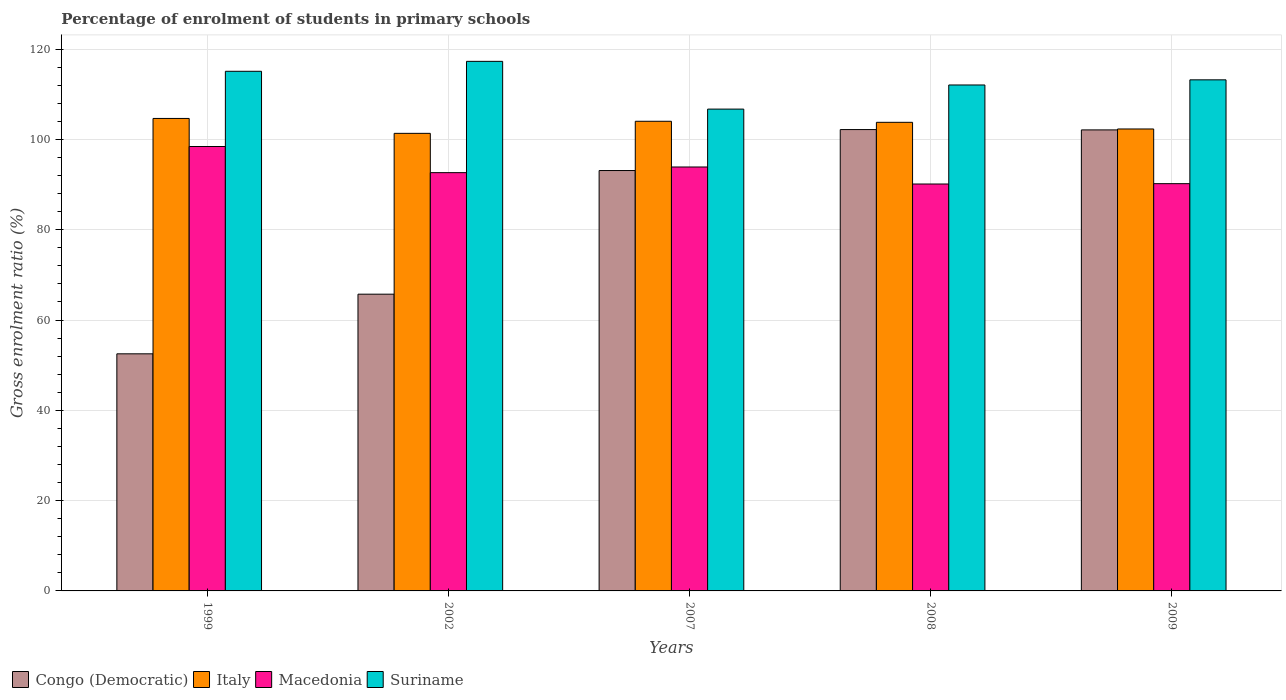What is the label of the 4th group of bars from the left?
Keep it short and to the point. 2008. In how many cases, is the number of bars for a given year not equal to the number of legend labels?
Keep it short and to the point. 0. What is the percentage of students enrolled in primary schools in Congo (Democratic) in 2002?
Your answer should be compact. 65.73. Across all years, what is the maximum percentage of students enrolled in primary schools in Macedonia?
Your answer should be very brief. 98.43. Across all years, what is the minimum percentage of students enrolled in primary schools in Macedonia?
Offer a terse response. 90.13. In which year was the percentage of students enrolled in primary schools in Congo (Democratic) maximum?
Provide a succinct answer. 2008. What is the total percentage of students enrolled in primary schools in Italy in the graph?
Ensure brevity in your answer.  516.12. What is the difference between the percentage of students enrolled in primary schools in Suriname in 2002 and that in 2009?
Keep it short and to the point. 4.09. What is the difference between the percentage of students enrolled in primary schools in Suriname in 2002 and the percentage of students enrolled in primary schools in Congo (Democratic) in 1999?
Offer a very short reply. 64.78. What is the average percentage of students enrolled in primary schools in Suriname per year?
Provide a short and direct response. 112.87. In the year 1999, what is the difference between the percentage of students enrolled in primary schools in Suriname and percentage of students enrolled in primary schools in Italy?
Provide a succinct answer. 10.45. In how many years, is the percentage of students enrolled in primary schools in Congo (Democratic) greater than 84 %?
Make the answer very short. 3. What is the ratio of the percentage of students enrolled in primary schools in Suriname in 1999 to that in 2008?
Your response must be concise. 1.03. Is the percentage of students enrolled in primary schools in Congo (Democratic) in 2007 less than that in 2008?
Give a very brief answer. Yes. Is the difference between the percentage of students enrolled in primary schools in Suriname in 1999 and 2009 greater than the difference between the percentage of students enrolled in primary schools in Italy in 1999 and 2009?
Your answer should be compact. No. What is the difference between the highest and the second highest percentage of students enrolled in primary schools in Italy?
Offer a terse response. 0.62. What is the difference between the highest and the lowest percentage of students enrolled in primary schools in Suriname?
Provide a short and direct response. 10.58. Is the sum of the percentage of students enrolled in primary schools in Congo (Democratic) in 1999 and 2008 greater than the maximum percentage of students enrolled in primary schools in Suriname across all years?
Ensure brevity in your answer.  Yes. What does the 3rd bar from the left in 1999 represents?
Make the answer very short. Macedonia. What does the 3rd bar from the right in 2009 represents?
Keep it short and to the point. Italy. How many bars are there?
Ensure brevity in your answer.  20. Are all the bars in the graph horizontal?
Provide a short and direct response. No. How many years are there in the graph?
Make the answer very short. 5. Does the graph contain any zero values?
Your answer should be very brief. No. How many legend labels are there?
Your answer should be very brief. 4. What is the title of the graph?
Provide a succinct answer. Percentage of enrolment of students in primary schools. What is the Gross enrolment ratio (%) in Congo (Democratic) in 1999?
Keep it short and to the point. 52.51. What is the Gross enrolment ratio (%) in Italy in 1999?
Give a very brief answer. 104.65. What is the Gross enrolment ratio (%) of Macedonia in 1999?
Ensure brevity in your answer.  98.43. What is the Gross enrolment ratio (%) of Suriname in 1999?
Your answer should be very brief. 115.09. What is the Gross enrolment ratio (%) of Congo (Democratic) in 2002?
Keep it short and to the point. 65.73. What is the Gross enrolment ratio (%) of Italy in 2002?
Keep it short and to the point. 101.35. What is the Gross enrolment ratio (%) of Macedonia in 2002?
Your response must be concise. 92.64. What is the Gross enrolment ratio (%) in Suriname in 2002?
Give a very brief answer. 117.29. What is the Gross enrolment ratio (%) in Congo (Democratic) in 2007?
Your response must be concise. 93.11. What is the Gross enrolment ratio (%) of Italy in 2007?
Keep it short and to the point. 104.02. What is the Gross enrolment ratio (%) in Macedonia in 2007?
Your response must be concise. 93.9. What is the Gross enrolment ratio (%) in Suriname in 2007?
Provide a short and direct response. 106.72. What is the Gross enrolment ratio (%) in Congo (Democratic) in 2008?
Make the answer very short. 102.18. What is the Gross enrolment ratio (%) of Italy in 2008?
Offer a very short reply. 103.79. What is the Gross enrolment ratio (%) in Macedonia in 2008?
Your answer should be very brief. 90.13. What is the Gross enrolment ratio (%) of Suriname in 2008?
Provide a succinct answer. 112.06. What is the Gross enrolment ratio (%) in Congo (Democratic) in 2009?
Make the answer very short. 102.11. What is the Gross enrolment ratio (%) of Italy in 2009?
Your answer should be compact. 102.32. What is the Gross enrolment ratio (%) in Macedonia in 2009?
Your answer should be compact. 90.2. What is the Gross enrolment ratio (%) of Suriname in 2009?
Give a very brief answer. 113.2. Across all years, what is the maximum Gross enrolment ratio (%) of Congo (Democratic)?
Offer a very short reply. 102.18. Across all years, what is the maximum Gross enrolment ratio (%) of Italy?
Make the answer very short. 104.65. Across all years, what is the maximum Gross enrolment ratio (%) of Macedonia?
Make the answer very short. 98.43. Across all years, what is the maximum Gross enrolment ratio (%) in Suriname?
Your response must be concise. 117.29. Across all years, what is the minimum Gross enrolment ratio (%) of Congo (Democratic)?
Your answer should be very brief. 52.51. Across all years, what is the minimum Gross enrolment ratio (%) in Italy?
Your response must be concise. 101.35. Across all years, what is the minimum Gross enrolment ratio (%) in Macedonia?
Give a very brief answer. 90.13. Across all years, what is the minimum Gross enrolment ratio (%) in Suriname?
Provide a succinct answer. 106.72. What is the total Gross enrolment ratio (%) of Congo (Democratic) in the graph?
Your response must be concise. 415.64. What is the total Gross enrolment ratio (%) of Italy in the graph?
Give a very brief answer. 516.12. What is the total Gross enrolment ratio (%) in Macedonia in the graph?
Your response must be concise. 465.3. What is the total Gross enrolment ratio (%) of Suriname in the graph?
Your response must be concise. 564.36. What is the difference between the Gross enrolment ratio (%) in Congo (Democratic) in 1999 and that in 2002?
Offer a terse response. -13.21. What is the difference between the Gross enrolment ratio (%) of Italy in 1999 and that in 2002?
Your response must be concise. 3.3. What is the difference between the Gross enrolment ratio (%) of Macedonia in 1999 and that in 2002?
Make the answer very short. 5.79. What is the difference between the Gross enrolment ratio (%) of Suriname in 1999 and that in 2002?
Offer a terse response. -2.2. What is the difference between the Gross enrolment ratio (%) of Congo (Democratic) in 1999 and that in 2007?
Your response must be concise. -40.59. What is the difference between the Gross enrolment ratio (%) of Italy in 1999 and that in 2007?
Provide a succinct answer. 0.62. What is the difference between the Gross enrolment ratio (%) of Macedonia in 1999 and that in 2007?
Make the answer very short. 4.54. What is the difference between the Gross enrolment ratio (%) in Suriname in 1999 and that in 2007?
Your answer should be very brief. 8.38. What is the difference between the Gross enrolment ratio (%) of Congo (Democratic) in 1999 and that in 2008?
Provide a short and direct response. -49.67. What is the difference between the Gross enrolment ratio (%) of Italy in 1999 and that in 2008?
Make the answer very short. 0.86. What is the difference between the Gross enrolment ratio (%) of Macedonia in 1999 and that in 2008?
Keep it short and to the point. 8.31. What is the difference between the Gross enrolment ratio (%) of Suriname in 1999 and that in 2008?
Offer a very short reply. 3.03. What is the difference between the Gross enrolment ratio (%) in Congo (Democratic) in 1999 and that in 2009?
Provide a succinct answer. -49.6. What is the difference between the Gross enrolment ratio (%) of Italy in 1999 and that in 2009?
Your answer should be compact. 2.33. What is the difference between the Gross enrolment ratio (%) in Macedonia in 1999 and that in 2009?
Offer a terse response. 8.23. What is the difference between the Gross enrolment ratio (%) in Suriname in 1999 and that in 2009?
Offer a very short reply. 1.89. What is the difference between the Gross enrolment ratio (%) in Congo (Democratic) in 2002 and that in 2007?
Make the answer very short. -27.38. What is the difference between the Gross enrolment ratio (%) in Italy in 2002 and that in 2007?
Offer a very short reply. -2.68. What is the difference between the Gross enrolment ratio (%) in Macedonia in 2002 and that in 2007?
Offer a very short reply. -1.25. What is the difference between the Gross enrolment ratio (%) in Suriname in 2002 and that in 2007?
Provide a succinct answer. 10.58. What is the difference between the Gross enrolment ratio (%) in Congo (Democratic) in 2002 and that in 2008?
Offer a terse response. -36.46. What is the difference between the Gross enrolment ratio (%) in Italy in 2002 and that in 2008?
Offer a terse response. -2.44. What is the difference between the Gross enrolment ratio (%) of Macedonia in 2002 and that in 2008?
Your answer should be compact. 2.52. What is the difference between the Gross enrolment ratio (%) in Suriname in 2002 and that in 2008?
Give a very brief answer. 5.23. What is the difference between the Gross enrolment ratio (%) of Congo (Democratic) in 2002 and that in 2009?
Offer a very short reply. -36.38. What is the difference between the Gross enrolment ratio (%) in Italy in 2002 and that in 2009?
Your response must be concise. -0.97. What is the difference between the Gross enrolment ratio (%) of Macedonia in 2002 and that in 2009?
Provide a short and direct response. 2.44. What is the difference between the Gross enrolment ratio (%) in Suriname in 2002 and that in 2009?
Keep it short and to the point. 4.09. What is the difference between the Gross enrolment ratio (%) in Congo (Democratic) in 2007 and that in 2008?
Your response must be concise. -9.08. What is the difference between the Gross enrolment ratio (%) in Italy in 2007 and that in 2008?
Your answer should be compact. 0.23. What is the difference between the Gross enrolment ratio (%) in Macedonia in 2007 and that in 2008?
Ensure brevity in your answer.  3.77. What is the difference between the Gross enrolment ratio (%) of Suriname in 2007 and that in 2008?
Ensure brevity in your answer.  -5.34. What is the difference between the Gross enrolment ratio (%) in Congo (Democratic) in 2007 and that in 2009?
Provide a succinct answer. -9. What is the difference between the Gross enrolment ratio (%) in Italy in 2007 and that in 2009?
Offer a terse response. 1.71. What is the difference between the Gross enrolment ratio (%) of Macedonia in 2007 and that in 2009?
Provide a short and direct response. 3.69. What is the difference between the Gross enrolment ratio (%) of Suriname in 2007 and that in 2009?
Your answer should be very brief. -6.48. What is the difference between the Gross enrolment ratio (%) of Congo (Democratic) in 2008 and that in 2009?
Provide a succinct answer. 0.07. What is the difference between the Gross enrolment ratio (%) in Italy in 2008 and that in 2009?
Your answer should be compact. 1.47. What is the difference between the Gross enrolment ratio (%) in Macedonia in 2008 and that in 2009?
Your response must be concise. -0.08. What is the difference between the Gross enrolment ratio (%) of Suriname in 2008 and that in 2009?
Provide a succinct answer. -1.14. What is the difference between the Gross enrolment ratio (%) in Congo (Democratic) in 1999 and the Gross enrolment ratio (%) in Italy in 2002?
Keep it short and to the point. -48.83. What is the difference between the Gross enrolment ratio (%) of Congo (Democratic) in 1999 and the Gross enrolment ratio (%) of Macedonia in 2002?
Give a very brief answer. -40.13. What is the difference between the Gross enrolment ratio (%) of Congo (Democratic) in 1999 and the Gross enrolment ratio (%) of Suriname in 2002?
Your answer should be compact. -64.78. What is the difference between the Gross enrolment ratio (%) in Italy in 1999 and the Gross enrolment ratio (%) in Macedonia in 2002?
Your answer should be compact. 12. What is the difference between the Gross enrolment ratio (%) of Italy in 1999 and the Gross enrolment ratio (%) of Suriname in 2002?
Give a very brief answer. -12.65. What is the difference between the Gross enrolment ratio (%) in Macedonia in 1999 and the Gross enrolment ratio (%) in Suriname in 2002?
Provide a short and direct response. -18.86. What is the difference between the Gross enrolment ratio (%) of Congo (Democratic) in 1999 and the Gross enrolment ratio (%) of Italy in 2007?
Keep it short and to the point. -51.51. What is the difference between the Gross enrolment ratio (%) in Congo (Democratic) in 1999 and the Gross enrolment ratio (%) in Macedonia in 2007?
Ensure brevity in your answer.  -41.38. What is the difference between the Gross enrolment ratio (%) of Congo (Democratic) in 1999 and the Gross enrolment ratio (%) of Suriname in 2007?
Ensure brevity in your answer.  -54.2. What is the difference between the Gross enrolment ratio (%) of Italy in 1999 and the Gross enrolment ratio (%) of Macedonia in 2007?
Provide a succinct answer. 10.75. What is the difference between the Gross enrolment ratio (%) in Italy in 1999 and the Gross enrolment ratio (%) in Suriname in 2007?
Make the answer very short. -2.07. What is the difference between the Gross enrolment ratio (%) of Macedonia in 1999 and the Gross enrolment ratio (%) of Suriname in 2007?
Provide a short and direct response. -8.28. What is the difference between the Gross enrolment ratio (%) of Congo (Democratic) in 1999 and the Gross enrolment ratio (%) of Italy in 2008?
Offer a very short reply. -51.28. What is the difference between the Gross enrolment ratio (%) in Congo (Democratic) in 1999 and the Gross enrolment ratio (%) in Macedonia in 2008?
Ensure brevity in your answer.  -37.61. What is the difference between the Gross enrolment ratio (%) of Congo (Democratic) in 1999 and the Gross enrolment ratio (%) of Suriname in 2008?
Ensure brevity in your answer.  -59.55. What is the difference between the Gross enrolment ratio (%) of Italy in 1999 and the Gross enrolment ratio (%) of Macedonia in 2008?
Offer a terse response. 14.52. What is the difference between the Gross enrolment ratio (%) of Italy in 1999 and the Gross enrolment ratio (%) of Suriname in 2008?
Offer a terse response. -7.41. What is the difference between the Gross enrolment ratio (%) of Macedonia in 1999 and the Gross enrolment ratio (%) of Suriname in 2008?
Ensure brevity in your answer.  -13.63. What is the difference between the Gross enrolment ratio (%) of Congo (Democratic) in 1999 and the Gross enrolment ratio (%) of Italy in 2009?
Offer a terse response. -49.8. What is the difference between the Gross enrolment ratio (%) in Congo (Democratic) in 1999 and the Gross enrolment ratio (%) in Macedonia in 2009?
Ensure brevity in your answer.  -37.69. What is the difference between the Gross enrolment ratio (%) of Congo (Democratic) in 1999 and the Gross enrolment ratio (%) of Suriname in 2009?
Provide a succinct answer. -60.69. What is the difference between the Gross enrolment ratio (%) in Italy in 1999 and the Gross enrolment ratio (%) in Macedonia in 2009?
Provide a short and direct response. 14.44. What is the difference between the Gross enrolment ratio (%) of Italy in 1999 and the Gross enrolment ratio (%) of Suriname in 2009?
Your answer should be very brief. -8.55. What is the difference between the Gross enrolment ratio (%) in Macedonia in 1999 and the Gross enrolment ratio (%) in Suriname in 2009?
Give a very brief answer. -14.77. What is the difference between the Gross enrolment ratio (%) in Congo (Democratic) in 2002 and the Gross enrolment ratio (%) in Italy in 2007?
Give a very brief answer. -38.3. What is the difference between the Gross enrolment ratio (%) in Congo (Democratic) in 2002 and the Gross enrolment ratio (%) in Macedonia in 2007?
Ensure brevity in your answer.  -28.17. What is the difference between the Gross enrolment ratio (%) of Congo (Democratic) in 2002 and the Gross enrolment ratio (%) of Suriname in 2007?
Make the answer very short. -40.99. What is the difference between the Gross enrolment ratio (%) in Italy in 2002 and the Gross enrolment ratio (%) in Macedonia in 2007?
Provide a short and direct response. 7.45. What is the difference between the Gross enrolment ratio (%) in Italy in 2002 and the Gross enrolment ratio (%) in Suriname in 2007?
Offer a very short reply. -5.37. What is the difference between the Gross enrolment ratio (%) in Macedonia in 2002 and the Gross enrolment ratio (%) in Suriname in 2007?
Offer a terse response. -14.07. What is the difference between the Gross enrolment ratio (%) in Congo (Democratic) in 2002 and the Gross enrolment ratio (%) in Italy in 2008?
Offer a terse response. -38.06. What is the difference between the Gross enrolment ratio (%) of Congo (Democratic) in 2002 and the Gross enrolment ratio (%) of Macedonia in 2008?
Provide a short and direct response. -24.4. What is the difference between the Gross enrolment ratio (%) in Congo (Democratic) in 2002 and the Gross enrolment ratio (%) in Suriname in 2008?
Provide a succinct answer. -46.33. What is the difference between the Gross enrolment ratio (%) in Italy in 2002 and the Gross enrolment ratio (%) in Macedonia in 2008?
Make the answer very short. 11.22. What is the difference between the Gross enrolment ratio (%) of Italy in 2002 and the Gross enrolment ratio (%) of Suriname in 2008?
Your answer should be very brief. -10.71. What is the difference between the Gross enrolment ratio (%) of Macedonia in 2002 and the Gross enrolment ratio (%) of Suriname in 2008?
Your response must be concise. -19.42. What is the difference between the Gross enrolment ratio (%) in Congo (Democratic) in 2002 and the Gross enrolment ratio (%) in Italy in 2009?
Your response must be concise. -36.59. What is the difference between the Gross enrolment ratio (%) of Congo (Democratic) in 2002 and the Gross enrolment ratio (%) of Macedonia in 2009?
Offer a terse response. -24.48. What is the difference between the Gross enrolment ratio (%) in Congo (Democratic) in 2002 and the Gross enrolment ratio (%) in Suriname in 2009?
Your answer should be very brief. -47.47. What is the difference between the Gross enrolment ratio (%) of Italy in 2002 and the Gross enrolment ratio (%) of Macedonia in 2009?
Ensure brevity in your answer.  11.14. What is the difference between the Gross enrolment ratio (%) in Italy in 2002 and the Gross enrolment ratio (%) in Suriname in 2009?
Keep it short and to the point. -11.85. What is the difference between the Gross enrolment ratio (%) in Macedonia in 2002 and the Gross enrolment ratio (%) in Suriname in 2009?
Provide a short and direct response. -20.56. What is the difference between the Gross enrolment ratio (%) of Congo (Democratic) in 2007 and the Gross enrolment ratio (%) of Italy in 2008?
Give a very brief answer. -10.68. What is the difference between the Gross enrolment ratio (%) in Congo (Democratic) in 2007 and the Gross enrolment ratio (%) in Macedonia in 2008?
Keep it short and to the point. 2.98. What is the difference between the Gross enrolment ratio (%) in Congo (Democratic) in 2007 and the Gross enrolment ratio (%) in Suriname in 2008?
Offer a very short reply. -18.95. What is the difference between the Gross enrolment ratio (%) of Italy in 2007 and the Gross enrolment ratio (%) of Macedonia in 2008?
Your answer should be compact. 13.9. What is the difference between the Gross enrolment ratio (%) in Italy in 2007 and the Gross enrolment ratio (%) in Suriname in 2008?
Provide a short and direct response. -8.04. What is the difference between the Gross enrolment ratio (%) of Macedonia in 2007 and the Gross enrolment ratio (%) of Suriname in 2008?
Provide a succinct answer. -18.16. What is the difference between the Gross enrolment ratio (%) in Congo (Democratic) in 2007 and the Gross enrolment ratio (%) in Italy in 2009?
Provide a succinct answer. -9.21. What is the difference between the Gross enrolment ratio (%) in Congo (Democratic) in 2007 and the Gross enrolment ratio (%) in Macedonia in 2009?
Offer a terse response. 2.91. What is the difference between the Gross enrolment ratio (%) of Congo (Democratic) in 2007 and the Gross enrolment ratio (%) of Suriname in 2009?
Keep it short and to the point. -20.09. What is the difference between the Gross enrolment ratio (%) in Italy in 2007 and the Gross enrolment ratio (%) in Macedonia in 2009?
Give a very brief answer. 13.82. What is the difference between the Gross enrolment ratio (%) in Italy in 2007 and the Gross enrolment ratio (%) in Suriname in 2009?
Offer a terse response. -9.18. What is the difference between the Gross enrolment ratio (%) in Macedonia in 2007 and the Gross enrolment ratio (%) in Suriname in 2009?
Your answer should be compact. -19.3. What is the difference between the Gross enrolment ratio (%) of Congo (Democratic) in 2008 and the Gross enrolment ratio (%) of Italy in 2009?
Offer a terse response. -0.13. What is the difference between the Gross enrolment ratio (%) in Congo (Democratic) in 2008 and the Gross enrolment ratio (%) in Macedonia in 2009?
Ensure brevity in your answer.  11.98. What is the difference between the Gross enrolment ratio (%) in Congo (Democratic) in 2008 and the Gross enrolment ratio (%) in Suriname in 2009?
Your response must be concise. -11.02. What is the difference between the Gross enrolment ratio (%) of Italy in 2008 and the Gross enrolment ratio (%) of Macedonia in 2009?
Make the answer very short. 13.59. What is the difference between the Gross enrolment ratio (%) of Italy in 2008 and the Gross enrolment ratio (%) of Suriname in 2009?
Offer a terse response. -9.41. What is the difference between the Gross enrolment ratio (%) in Macedonia in 2008 and the Gross enrolment ratio (%) in Suriname in 2009?
Offer a terse response. -23.07. What is the average Gross enrolment ratio (%) of Congo (Democratic) per year?
Keep it short and to the point. 83.13. What is the average Gross enrolment ratio (%) in Italy per year?
Offer a very short reply. 103.22. What is the average Gross enrolment ratio (%) in Macedonia per year?
Give a very brief answer. 93.06. What is the average Gross enrolment ratio (%) in Suriname per year?
Provide a short and direct response. 112.87. In the year 1999, what is the difference between the Gross enrolment ratio (%) in Congo (Democratic) and Gross enrolment ratio (%) in Italy?
Provide a succinct answer. -52.13. In the year 1999, what is the difference between the Gross enrolment ratio (%) in Congo (Democratic) and Gross enrolment ratio (%) in Macedonia?
Your answer should be very brief. -45.92. In the year 1999, what is the difference between the Gross enrolment ratio (%) of Congo (Democratic) and Gross enrolment ratio (%) of Suriname?
Offer a very short reply. -62.58. In the year 1999, what is the difference between the Gross enrolment ratio (%) in Italy and Gross enrolment ratio (%) in Macedonia?
Your answer should be compact. 6.21. In the year 1999, what is the difference between the Gross enrolment ratio (%) of Italy and Gross enrolment ratio (%) of Suriname?
Offer a very short reply. -10.45. In the year 1999, what is the difference between the Gross enrolment ratio (%) in Macedonia and Gross enrolment ratio (%) in Suriname?
Offer a very short reply. -16.66. In the year 2002, what is the difference between the Gross enrolment ratio (%) in Congo (Democratic) and Gross enrolment ratio (%) in Italy?
Give a very brief answer. -35.62. In the year 2002, what is the difference between the Gross enrolment ratio (%) of Congo (Democratic) and Gross enrolment ratio (%) of Macedonia?
Give a very brief answer. -26.92. In the year 2002, what is the difference between the Gross enrolment ratio (%) in Congo (Democratic) and Gross enrolment ratio (%) in Suriname?
Your answer should be compact. -51.57. In the year 2002, what is the difference between the Gross enrolment ratio (%) in Italy and Gross enrolment ratio (%) in Macedonia?
Keep it short and to the point. 8.7. In the year 2002, what is the difference between the Gross enrolment ratio (%) in Italy and Gross enrolment ratio (%) in Suriname?
Provide a succinct answer. -15.95. In the year 2002, what is the difference between the Gross enrolment ratio (%) of Macedonia and Gross enrolment ratio (%) of Suriname?
Your response must be concise. -24.65. In the year 2007, what is the difference between the Gross enrolment ratio (%) of Congo (Democratic) and Gross enrolment ratio (%) of Italy?
Ensure brevity in your answer.  -10.91. In the year 2007, what is the difference between the Gross enrolment ratio (%) in Congo (Democratic) and Gross enrolment ratio (%) in Macedonia?
Ensure brevity in your answer.  -0.79. In the year 2007, what is the difference between the Gross enrolment ratio (%) in Congo (Democratic) and Gross enrolment ratio (%) in Suriname?
Provide a succinct answer. -13.61. In the year 2007, what is the difference between the Gross enrolment ratio (%) of Italy and Gross enrolment ratio (%) of Macedonia?
Keep it short and to the point. 10.13. In the year 2007, what is the difference between the Gross enrolment ratio (%) in Italy and Gross enrolment ratio (%) in Suriname?
Offer a terse response. -2.69. In the year 2007, what is the difference between the Gross enrolment ratio (%) in Macedonia and Gross enrolment ratio (%) in Suriname?
Make the answer very short. -12.82. In the year 2008, what is the difference between the Gross enrolment ratio (%) of Congo (Democratic) and Gross enrolment ratio (%) of Italy?
Your answer should be compact. -1.6. In the year 2008, what is the difference between the Gross enrolment ratio (%) in Congo (Democratic) and Gross enrolment ratio (%) in Macedonia?
Your answer should be compact. 12.06. In the year 2008, what is the difference between the Gross enrolment ratio (%) in Congo (Democratic) and Gross enrolment ratio (%) in Suriname?
Your answer should be very brief. -9.88. In the year 2008, what is the difference between the Gross enrolment ratio (%) in Italy and Gross enrolment ratio (%) in Macedonia?
Provide a succinct answer. 13.66. In the year 2008, what is the difference between the Gross enrolment ratio (%) in Italy and Gross enrolment ratio (%) in Suriname?
Provide a succinct answer. -8.27. In the year 2008, what is the difference between the Gross enrolment ratio (%) of Macedonia and Gross enrolment ratio (%) of Suriname?
Provide a short and direct response. -21.93. In the year 2009, what is the difference between the Gross enrolment ratio (%) of Congo (Democratic) and Gross enrolment ratio (%) of Italy?
Provide a succinct answer. -0.21. In the year 2009, what is the difference between the Gross enrolment ratio (%) of Congo (Democratic) and Gross enrolment ratio (%) of Macedonia?
Offer a terse response. 11.91. In the year 2009, what is the difference between the Gross enrolment ratio (%) in Congo (Democratic) and Gross enrolment ratio (%) in Suriname?
Make the answer very short. -11.09. In the year 2009, what is the difference between the Gross enrolment ratio (%) in Italy and Gross enrolment ratio (%) in Macedonia?
Your response must be concise. 12.11. In the year 2009, what is the difference between the Gross enrolment ratio (%) of Italy and Gross enrolment ratio (%) of Suriname?
Provide a short and direct response. -10.88. In the year 2009, what is the difference between the Gross enrolment ratio (%) in Macedonia and Gross enrolment ratio (%) in Suriname?
Give a very brief answer. -23. What is the ratio of the Gross enrolment ratio (%) in Congo (Democratic) in 1999 to that in 2002?
Your answer should be very brief. 0.8. What is the ratio of the Gross enrolment ratio (%) in Italy in 1999 to that in 2002?
Offer a terse response. 1.03. What is the ratio of the Gross enrolment ratio (%) in Suriname in 1999 to that in 2002?
Your answer should be compact. 0.98. What is the ratio of the Gross enrolment ratio (%) in Congo (Democratic) in 1999 to that in 2007?
Keep it short and to the point. 0.56. What is the ratio of the Gross enrolment ratio (%) of Macedonia in 1999 to that in 2007?
Your answer should be compact. 1.05. What is the ratio of the Gross enrolment ratio (%) in Suriname in 1999 to that in 2007?
Your answer should be very brief. 1.08. What is the ratio of the Gross enrolment ratio (%) in Congo (Democratic) in 1999 to that in 2008?
Keep it short and to the point. 0.51. What is the ratio of the Gross enrolment ratio (%) in Italy in 1999 to that in 2008?
Keep it short and to the point. 1.01. What is the ratio of the Gross enrolment ratio (%) in Macedonia in 1999 to that in 2008?
Give a very brief answer. 1.09. What is the ratio of the Gross enrolment ratio (%) of Suriname in 1999 to that in 2008?
Your answer should be very brief. 1.03. What is the ratio of the Gross enrolment ratio (%) in Congo (Democratic) in 1999 to that in 2009?
Ensure brevity in your answer.  0.51. What is the ratio of the Gross enrolment ratio (%) of Italy in 1999 to that in 2009?
Your answer should be compact. 1.02. What is the ratio of the Gross enrolment ratio (%) of Macedonia in 1999 to that in 2009?
Offer a very short reply. 1.09. What is the ratio of the Gross enrolment ratio (%) in Suriname in 1999 to that in 2009?
Offer a very short reply. 1.02. What is the ratio of the Gross enrolment ratio (%) of Congo (Democratic) in 2002 to that in 2007?
Offer a terse response. 0.71. What is the ratio of the Gross enrolment ratio (%) in Italy in 2002 to that in 2007?
Give a very brief answer. 0.97. What is the ratio of the Gross enrolment ratio (%) in Macedonia in 2002 to that in 2007?
Offer a very short reply. 0.99. What is the ratio of the Gross enrolment ratio (%) of Suriname in 2002 to that in 2007?
Provide a short and direct response. 1.1. What is the ratio of the Gross enrolment ratio (%) in Congo (Democratic) in 2002 to that in 2008?
Provide a succinct answer. 0.64. What is the ratio of the Gross enrolment ratio (%) of Italy in 2002 to that in 2008?
Make the answer very short. 0.98. What is the ratio of the Gross enrolment ratio (%) in Macedonia in 2002 to that in 2008?
Keep it short and to the point. 1.03. What is the ratio of the Gross enrolment ratio (%) of Suriname in 2002 to that in 2008?
Keep it short and to the point. 1.05. What is the ratio of the Gross enrolment ratio (%) in Congo (Democratic) in 2002 to that in 2009?
Your answer should be compact. 0.64. What is the ratio of the Gross enrolment ratio (%) of Italy in 2002 to that in 2009?
Your answer should be compact. 0.99. What is the ratio of the Gross enrolment ratio (%) in Macedonia in 2002 to that in 2009?
Provide a short and direct response. 1.03. What is the ratio of the Gross enrolment ratio (%) in Suriname in 2002 to that in 2009?
Offer a very short reply. 1.04. What is the ratio of the Gross enrolment ratio (%) of Congo (Democratic) in 2007 to that in 2008?
Make the answer very short. 0.91. What is the ratio of the Gross enrolment ratio (%) in Macedonia in 2007 to that in 2008?
Offer a very short reply. 1.04. What is the ratio of the Gross enrolment ratio (%) in Suriname in 2007 to that in 2008?
Offer a very short reply. 0.95. What is the ratio of the Gross enrolment ratio (%) of Congo (Democratic) in 2007 to that in 2009?
Offer a terse response. 0.91. What is the ratio of the Gross enrolment ratio (%) in Italy in 2007 to that in 2009?
Your answer should be compact. 1.02. What is the ratio of the Gross enrolment ratio (%) of Macedonia in 2007 to that in 2009?
Provide a short and direct response. 1.04. What is the ratio of the Gross enrolment ratio (%) of Suriname in 2007 to that in 2009?
Your answer should be very brief. 0.94. What is the ratio of the Gross enrolment ratio (%) in Italy in 2008 to that in 2009?
Keep it short and to the point. 1.01. What is the ratio of the Gross enrolment ratio (%) of Macedonia in 2008 to that in 2009?
Offer a very short reply. 1. What is the ratio of the Gross enrolment ratio (%) in Suriname in 2008 to that in 2009?
Make the answer very short. 0.99. What is the difference between the highest and the second highest Gross enrolment ratio (%) of Congo (Democratic)?
Offer a terse response. 0.07. What is the difference between the highest and the second highest Gross enrolment ratio (%) in Italy?
Ensure brevity in your answer.  0.62. What is the difference between the highest and the second highest Gross enrolment ratio (%) of Macedonia?
Your response must be concise. 4.54. What is the difference between the highest and the second highest Gross enrolment ratio (%) in Suriname?
Ensure brevity in your answer.  2.2. What is the difference between the highest and the lowest Gross enrolment ratio (%) in Congo (Democratic)?
Provide a short and direct response. 49.67. What is the difference between the highest and the lowest Gross enrolment ratio (%) of Italy?
Keep it short and to the point. 3.3. What is the difference between the highest and the lowest Gross enrolment ratio (%) of Macedonia?
Keep it short and to the point. 8.31. What is the difference between the highest and the lowest Gross enrolment ratio (%) in Suriname?
Keep it short and to the point. 10.58. 